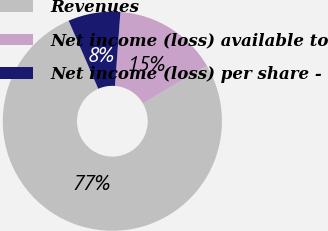Convert chart to OTSL. <chart><loc_0><loc_0><loc_500><loc_500><pie_chart><fcel>Revenues<fcel>Net income (loss) available to<fcel>Net income (loss) per share -<nl><fcel>76.91%<fcel>15.39%<fcel>7.7%<nl></chart> 